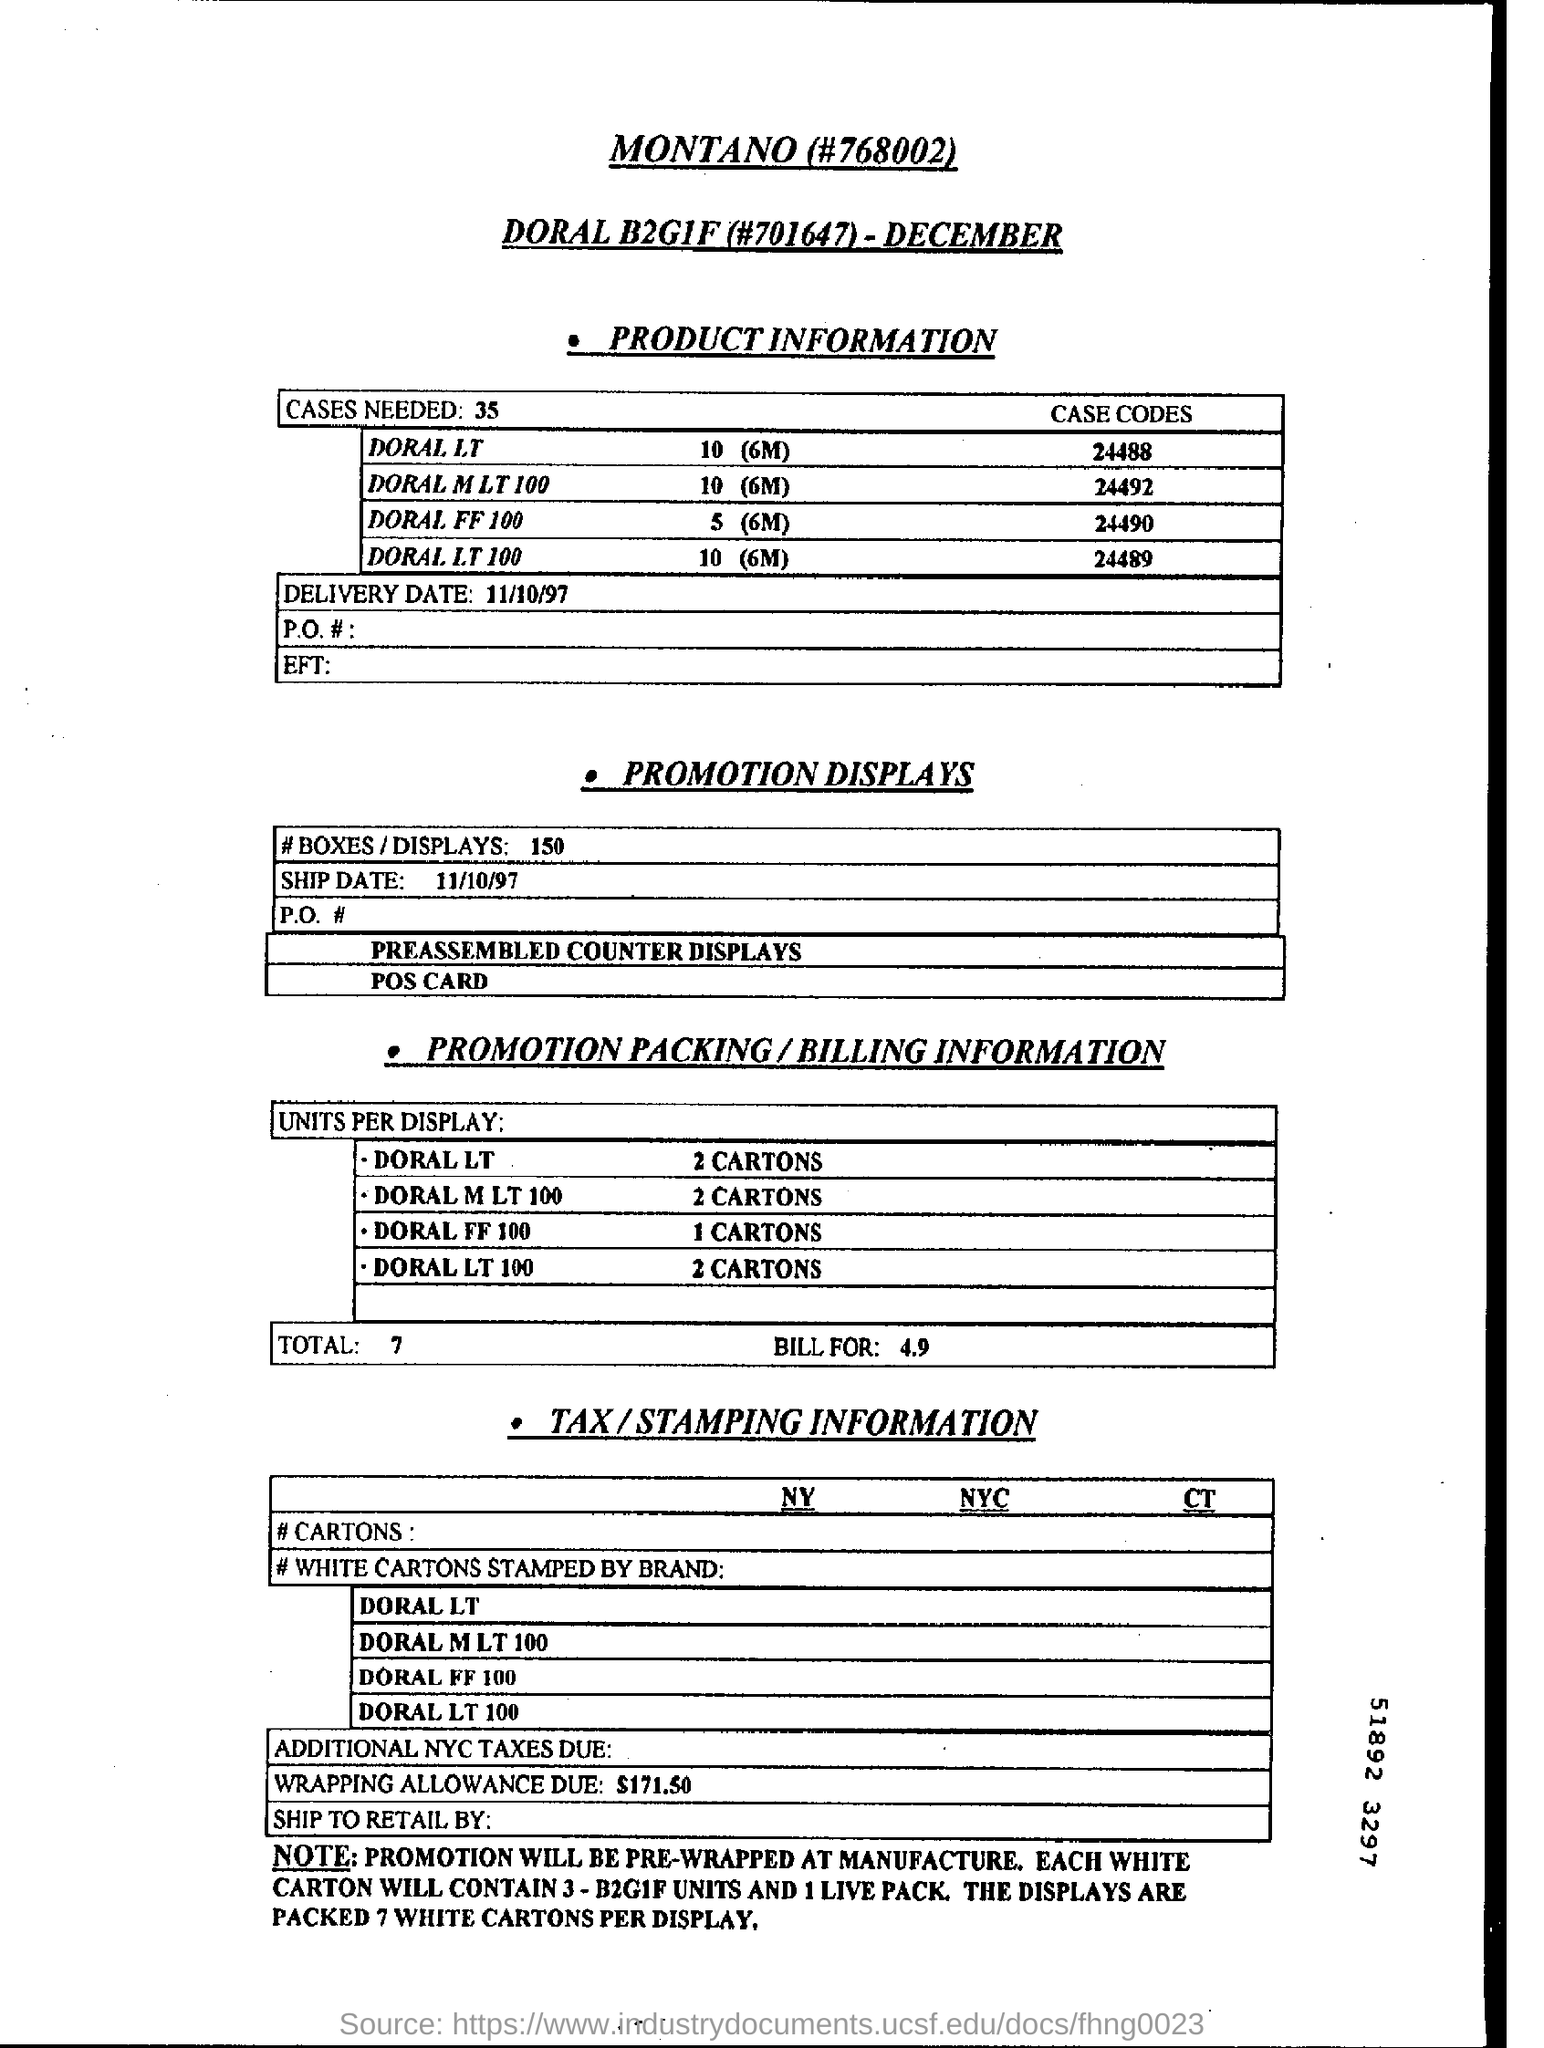Identify some key points in this picture. The delivery date is 11/10/97. The case code for DORAL LT is 24488. For DORAL LT 100, the recommended unit quantity per display is 2 cartons. The wrapping allowance due is $171.50. It is necessary to conduct 35 cases in order to... 